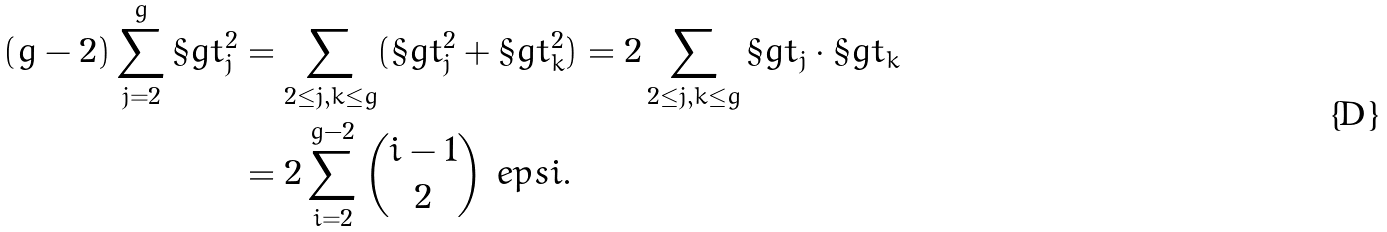<formula> <loc_0><loc_0><loc_500><loc_500>( g - 2 ) \sum _ { j = 2 } ^ { g } \S g t _ { j } ^ { 2 } & = \sum _ { 2 \leq j , k \leq g } ( \S g t _ { j } ^ { 2 } + \S g t _ { k } ^ { 2 } ) = 2 \sum _ { 2 \leq j , k \leq g } \S g t _ { j } \cdot \S g t _ { k } \\ & = 2 \sum _ { i = 2 } ^ { g - 2 } \binom { i - 1 } { 2 } \ e p s i \text {.}</formula> 